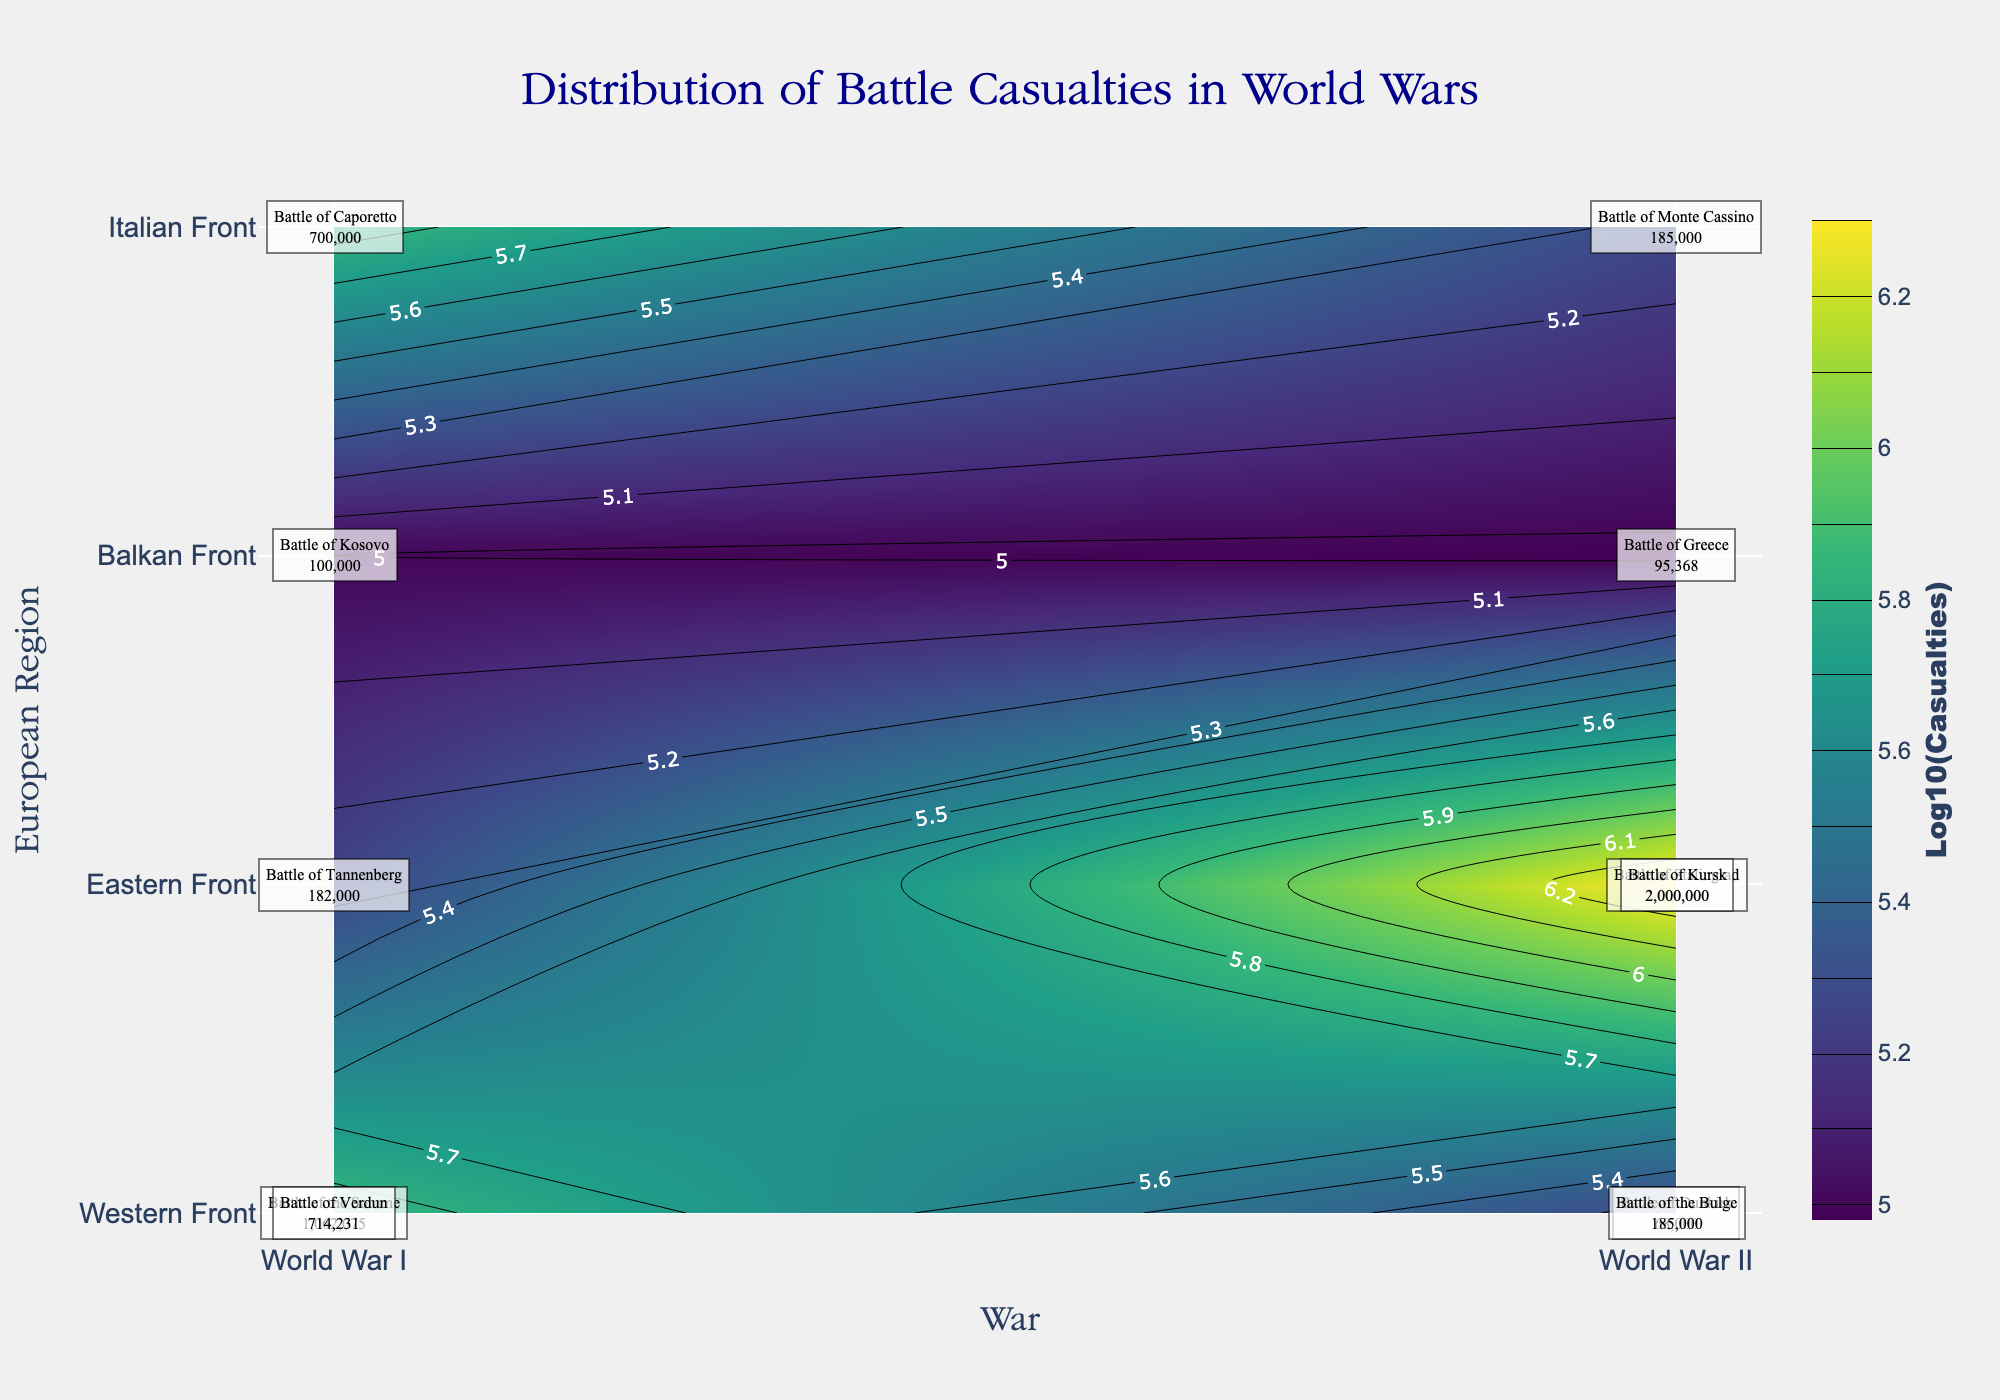What is the title of the contour plot? The title is positioned at the top center of the plot. It is prominently displayed in large font.
Answer: Distribution of Battle Casualties in World Wars Which battle resulted in the highest number of casualties? By examining the annotations and the color intensity in the contours, the Battle of Stalingrad and the Battle of Kursk both have the highest casualties, indicated by the darkest color.
Answer: Battle of Stalingrad, Battle of Kursk In which war did the Battle of Verdun occur? The Battle of Verdun is labeled on the plot, and its position in the x-axis indicates the associated war.
Answer: World War I What is the average number of casualties for battles on the Eastern Front during World War II? Identifying the battles on the Eastern Front during World War II and summing their casualties: Battle of Stalingrad (2,000,000), Battle of Kursk (2,000,000); then calculate the average: (2,000,000 + 2,000,000)/2 = 2,000,000
Answer: 2,000,000 Which war had a greater number of battles with casualties above one million? Compare the number of battles with casualties above one million in each war by examining the annotations: World War I (Battle of the Somme, Battle of Verdun) vs. World War II (Battle of Stalingrad, Battle of Kursk). Both wars have an equal number of such battles.
Answer: Both wars had 2 battles each How do the casualties in the Battle of Dunkirk compare to those in the Battle of Monte Cassino? Examine the annotations for these battles: Battle of Dunkirk (68,000) and Battle of Monte Cassino (185,000). Comparison shows that casualties in Monte Cassino are higher.
Answer: Monte Cassino had more casualties What European region experienced the Battle of Caporetto? The y-axis and annotations reveal the regions, showing the Battle of Caporetto is in the Italian Front.
Answer: Italian Front Which battle had the least casualties during World War II, and what region was it located in? From the annotations, identify the battle with the least casualties: Battle of Greece (95,368) and locate it in the y-axis.
Answer: Battle of Greece, Balkan Front What was the total number of casualties in battles on the Western Front during World War I? Summing the casualties from the Western Front battles during World War I: Battle of the Somme (1,062,075) + Battle of Verdun (714,231) = 1,776,306.
Answer: 1,776,306 How does the number of casualties in the Battle of Tannenberg compare to those in the Battle of the Bulge? Examine the annotations: Battle of Tannenberg (182,000) and Battle of the Bulge (185,000). The Battle of the Bulge has slightly more casualties.
Answer: Battle of the Bulge had more casualties 